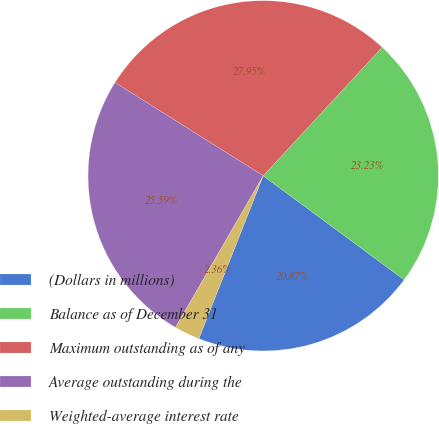Convert chart to OTSL. <chart><loc_0><loc_0><loc_500><loc_500><pie_chart><fcel>(Dollars in millions)<fcel>Balance as of December 31<fcel>Maximum outstanding as of any<fcel>Average outstanding during the<fcel>Weighted-average interest rate<nl><fcel>20.87%<fcel>23.23%<fcel>27.95%<fcel>25.59%<fcel>2.36%<nl></chart> 